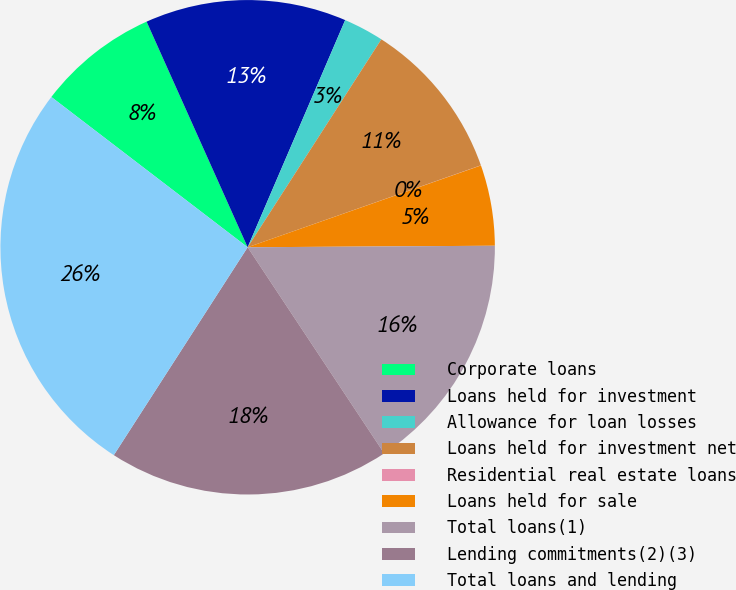Convert chart. <chart><loc_0><loc_0><loc_500><loc_500><pie_chart><fcel>Corporate loans<fcel>Loans held for investment<fcel>Allowance for loan losses<fcel>Loans held for investment net<fcel>Residential real estate loans<fcel>Loans held for sale<fcel>Total loans(1)<fcel>Lending commitments(2)(3)<fcel>Total loans and lending<nl><fcel>7.9%<fcel>13.16%<fcel>2.64%<fcel>10.53%<fcel>0.01%<fcel>5.27%<fcel>15.79%<fcel>18.42%<fcel>26.3%<nl></chart> 